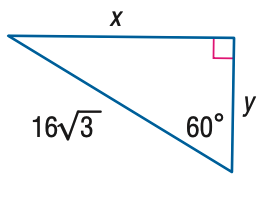Answer the mathemtical geometry problem and directly provide the correct option letter.
Question: Find x.
Choices: A: 8 \sqrt { 2 } B: 8 \sqrt { 3 } C: 16 D: 24 D 